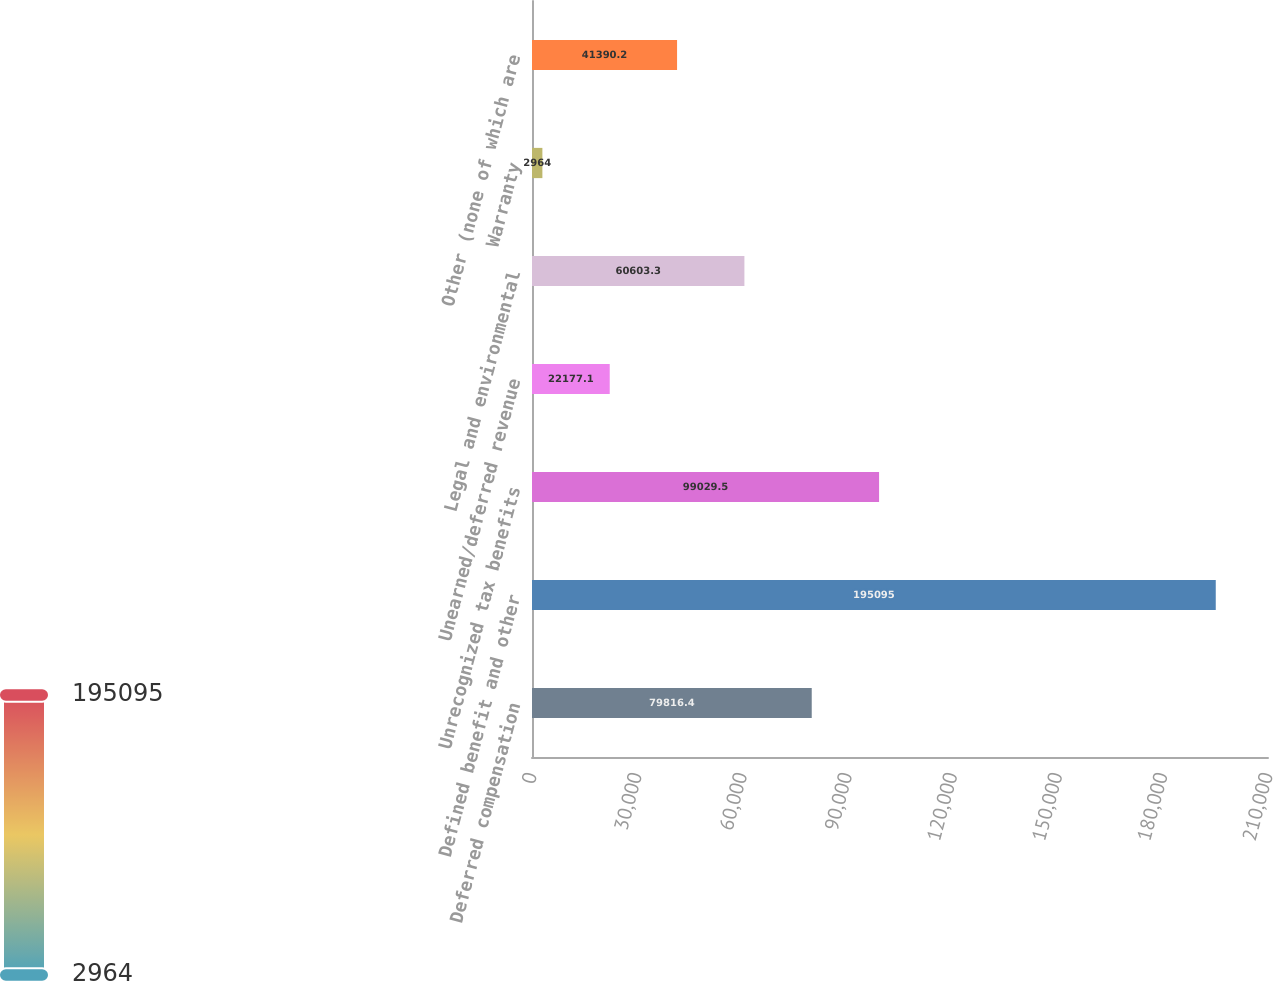<chart> <loc_0><loc_0><loc_500><loc_500><bar_chart><fcel>Deferred compensation<fcel>Defined benefit and other<fcel>Unrecognized tax benefits<fcel>Unearned/deferred revenue<fcel>Legal and environmental<fcel>Warranty<fcel>Other (none of which are<nl><fcel>79816.4<fcel>195095<fcel>99029.5<fcel>22177.1<fcel>60603.3<fcel>2964<fcel>41390.2<nl></chart> 